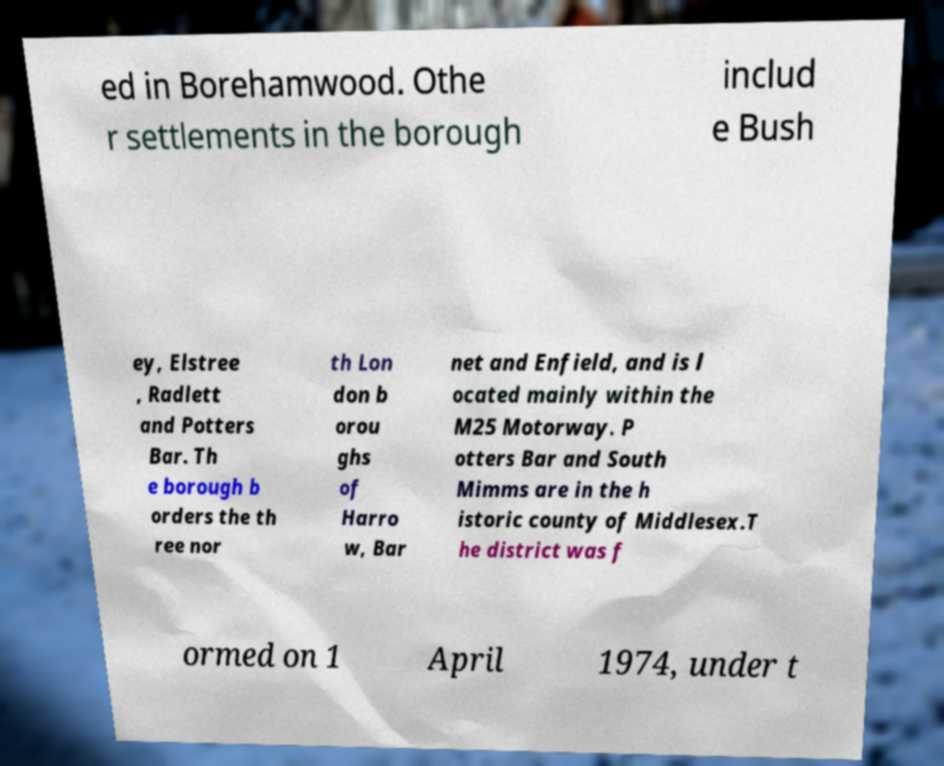Can you accurately transcribe the text from the provided image for me? ed in Borehamwood. Othe r settlements in the borough includ e Bush ey, Elstree , Radlett and Potters Bar. Th e borough b orders the th ree nor th Lon don b orou ghs of Harro w, Bar net and Enfield, and is l ocated mainly within the M25 Motorway. P otters Bar and South Mimms are in the h istoric county of Middlesex.T he district was f ormed on 1 April 1974, under t 